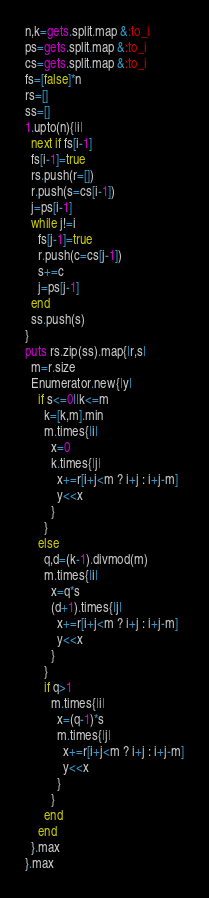Convert code to text. <code><loc_0><loc_0><loc_500><loc_500><_Ruby_>n,k=gets.split.map &:to_i
ps=gets.split.map &:to_i
cs=gets.split.map &:to_i
fs=[false]*n
rs=[]
ss=[]
1.upto(n){|i|
  next if fs[i-1]
  fs[i-1]=true
  rs.push(r=[])
  r.push(s=cs[i-1])
  j=ps[i-1]
  while j!=i
    fs[j-1]=true
    r.push(c=cs[j-1])
    s+=c
    j=ps[j-1]
  end
  ss.push(s)
}
puts rs.zip(ss).map{|r,s|
  m=r.size
  Enumerator.new{|y|
    if s<=0||k<=m
      k=[k,m].min
      m.times{|i|
        x=0
        k.times{|j|
          x+=r[i+j<m ? i+j : i+j-m]
          y<<x
        }
      }
    else
      q,d=(k-1).divmod(m)
      m.times{|i|
        x=q*s
        (d+1).times{|j|
          x+=r[i+j<m ? i+j : i+j-m]
          y<<x
        }
      }
      if q>1
        m.times{|i|
          x=(q-1)*s
          m.times{|j|
            x+=r[i+j<m ? i+j : i+j-m]
            y<<x
          }
        }
      end
    end
  }.max
}.max
</code> 